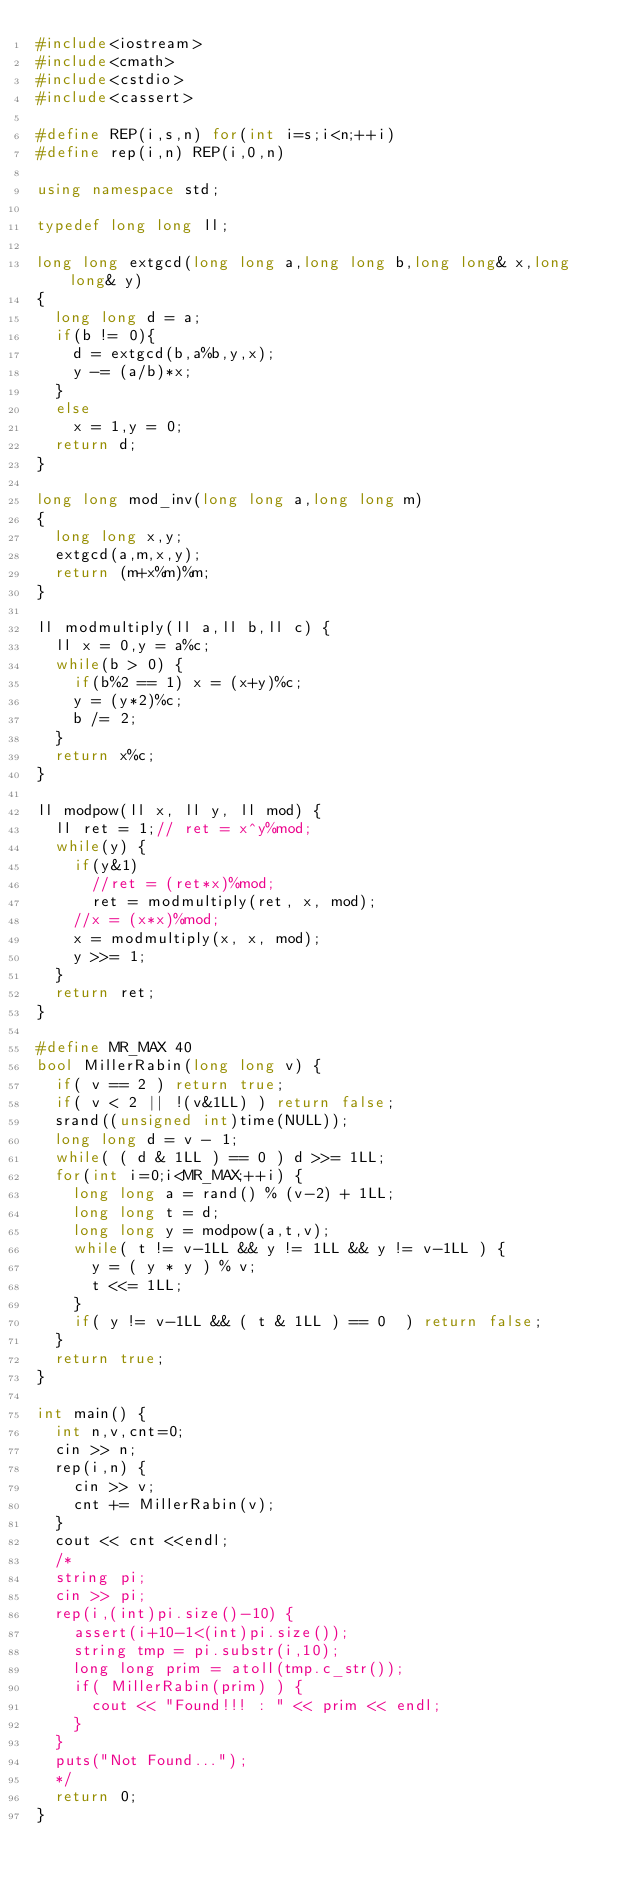<code> <loc_0><loc_0><loc_500><loc_500><_C++_>#include<iostream>
#include<cmath>
#include<cstdio>
#include<cassert>

#define REP(i,s,n) for(int i=s;i<n;++i)
#define rep(i,n) REP(i,0,n)

using namespace std;

typedef long long ll;

long long extgcd(long long a,long long b,long long& x,long long& y)
{
  long long d = a;
  if(b != 0){
    d = extgcd(b,a%b,y,x);
    y -= (a/b)*x;
  }
  else
    x = 1,y = 0;
  return d;
}

long long mod_inv(long long a,long long m)
{
  long long x,y;
  extgcd(a,m,x,y);
  return (m+x%m)%m;
}

ll modmultiply(ll a,ll b,ll c) {
  ll x = 0,y = a%c; 
  while(b > 0) {
    if(b%2 == 1) x = (x+y)%c; 
    y = (y*2)%c;
    b /= 2; 
  }
  return x%c;
}

ll modpow(ll x, ll y, ll mod) {
  ll ret = 1;// ret = x^y%mod;
  while(y) {
    if(y&1)
      //ret = (ret*x)%mod;
      ret = modmultiply(ret, x, mod);
    //x = (x*x)%mod;
    x = modmultiply(x, x, mod);
    y >>= 1;
  }
  return ret;
}

#define MR_MAX 40
bool MillerRabin(long long v) {
  if( v == 2 ) return true;
  if( v < 2 || !(v&1LL) ) return false;
  srand((unsigned int)time(NULL));
  long long d = v - 1;
  while( ( d & 1LL ) == 0 ) d >>= 1LL;
  for(int i=0;i<MR_MAX;++i) {
    long long a = rand() % (v-2) + 1LL;
    long long t = d;
    long long y = modpow(a,t,v);
    while( t != v-1LL && y != 1LL && y != v-1LL ) {
      y = ( y * y ) % v;
      t <<= 1LL;
    }
    if( y != v-1LL && ( t & 1LL ) == 0  ) return false;
  }
  return true;
}

int main() {
  int n,v,cnt=0;
  cin >> n;
  rep(i,n) {
    cin >> v;
    cnt += MillerRabin(v);
  }
  cout << cnt <<endl;
  /*
  string pi;
  cin >> pi;
  rep(i,(int)pi.size()-10) {
    assert(i+10-1<(int)pi.size());
    string tmp = pi.substr(i,10);
    long long prim = atoll(tmp.c_str());
    if( MillerRabin(prim) ) {
      cout << "Found!!! : " << prim << endl;
    }
  }
  puts("Not Found...");
  */
  return 0;
}</code> 